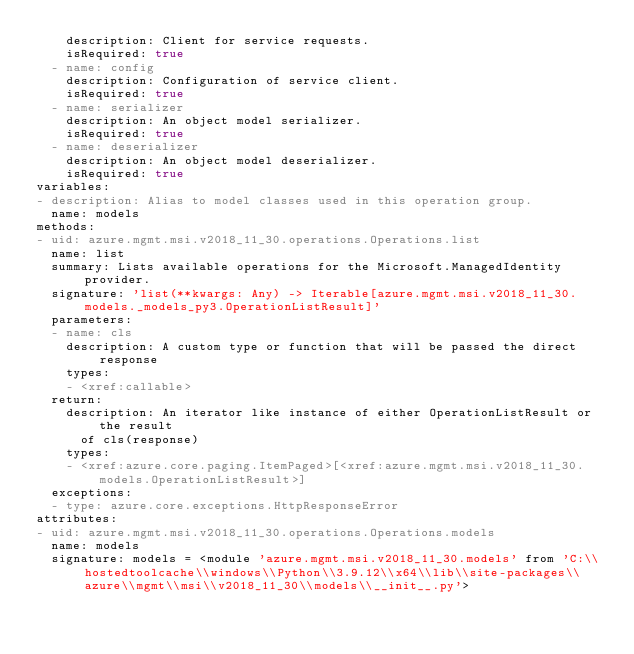<code> <loc_0><loc_0><loc_500><loc_500><_YAML_>    description: Client for service requests.
    isRequired: true
  - name: config
    description: Configuration of service client.
    isRequired: true
  - name: serializer
    description: An object model serializer.
    isRequired: true
  - name: deserializer
    description: An object model deserializer.
    isRequired: true
variables:
- description: Alias to model classes used in this operation group.
  name: models
methods:
- uid: azure.mgmt.msi.v2018_11_30.operations.Operations.list
  name: list
  summary: Lists available operations for the Microsoft.ManagedIdentity provider.
  signature: 'list(**kwargs: Any) -> Iterable[azure.mgmt.msi.v2018_11_30.models._models_py3.OperationListResult]'
  parameters:
  - name: cls
    description: A custom type or function that will be passed the direct response
    types:
    - <xref:callable>
  return:
    description: An iterator like instance of either OperationListResult or the result
      of cls(response)
    types:
    - <xref:azure.core.paging.ItemPaged>[<xref:azure.mgmt.msi.v2018_11_30.models.OperationListResult>]
  exceptions:
  - type: azure.core.exceptions.HttpResponseError
attributes:
- uid: azure.mgmt.msi.v2018_11_30.operations.Operations.models
  name: models
  signature: models = <module 'azure.mgmt.msi.v2018_11_30.models' from 'C:\\hostedtoolcache\\windows\\Python\\3.9.12\\x64\\lib\\site-packages\\azure\\mgmt\\msi\\v2018_11_30\\models\\__init__.py'>
</code> 